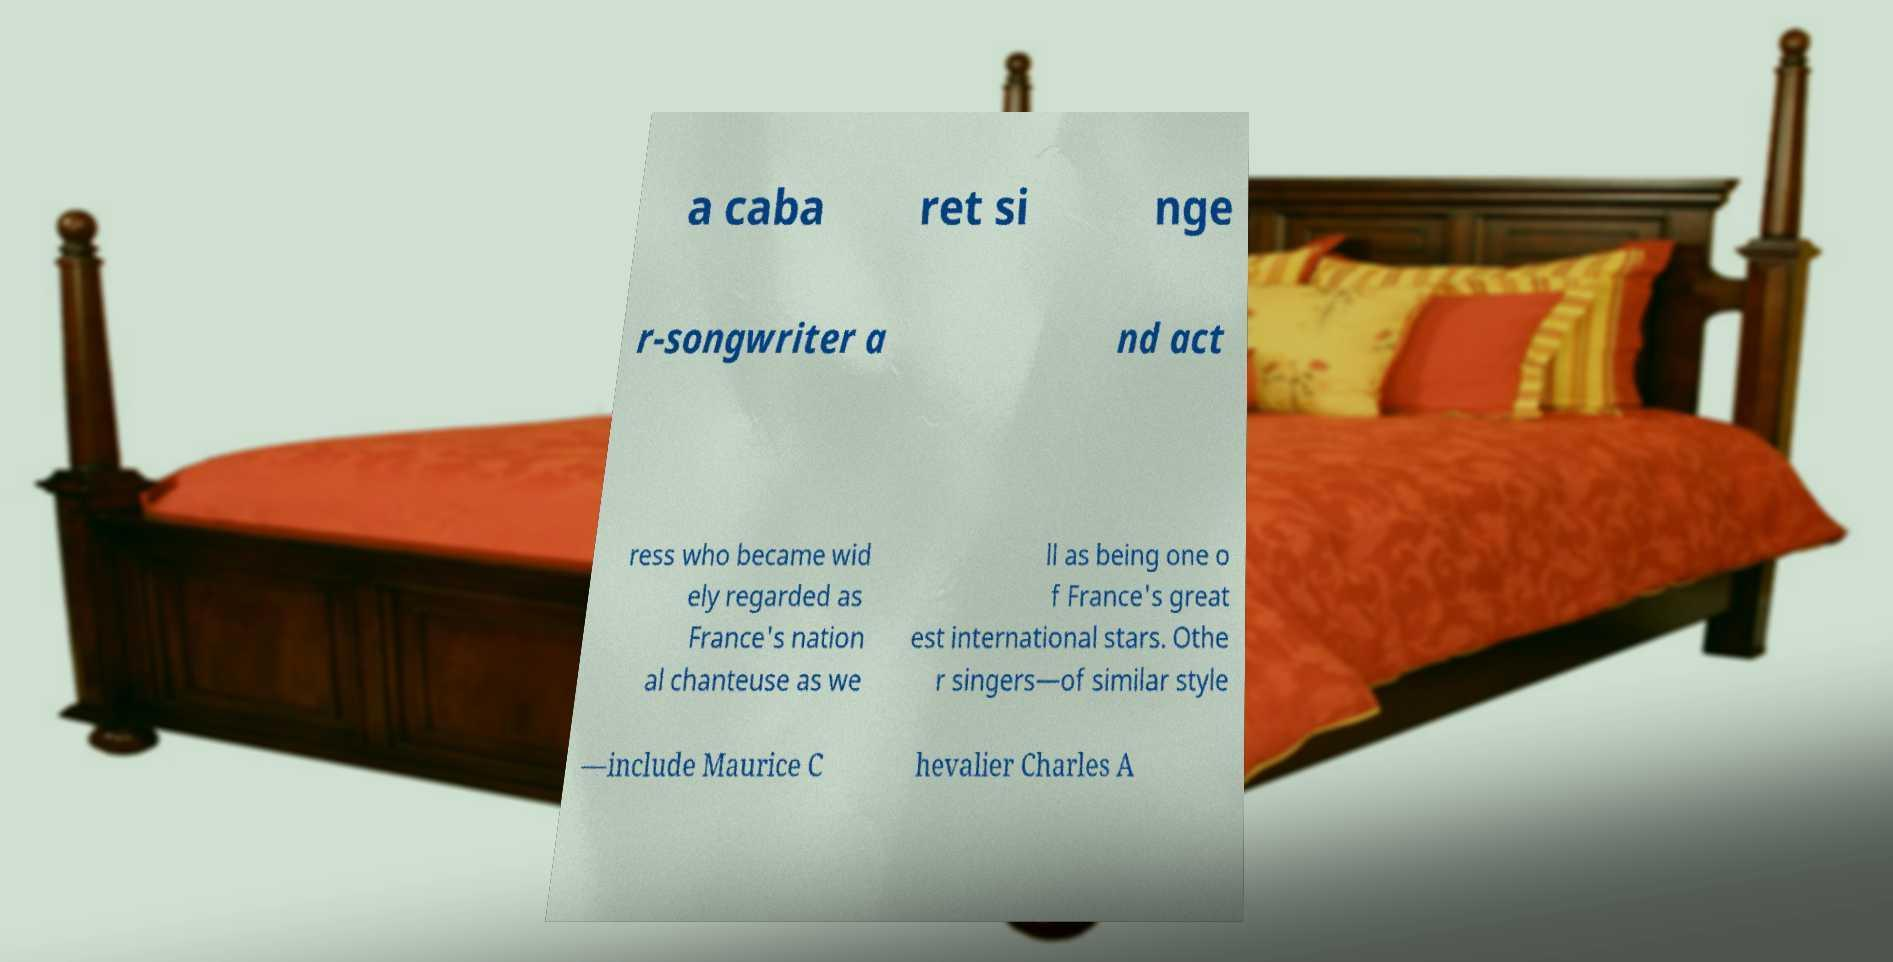Could you assist in decoding the text presented in this image and type it out clearly? a caba ret si nge r-songwriter a nd act ress who became wid ely regarded as France's nation al chanteuse as we ll as being one o f France's great est international stars. Othe r singers—of similar style —include Maurice C hevalier Charles A 